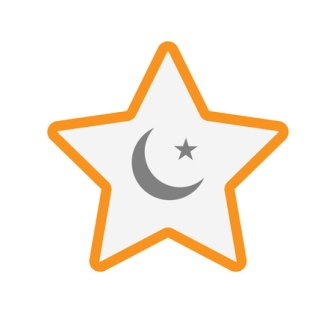What kind of story can you create with this symbol involving a mythical creature? In a realm where the skies are in constant twilight, there existed a legendary creature known as the Stellarion. This magnificent being was said to be birthed from a conjunction of the largest star and its moon. The Stellarion possessed the power to bring balance to the natural order. Whenever a shadow of chaos threatened the lands, the creature would emerge, its body glowing with the vibrant orange of the star and the calming gray of the moon. It was believed that the Stellarion could control the tides, summon rain, and even guide lost souls through the night. Its presence was a beacon of hope and harmony, reminding all of the intrinsic balance of the universe. Describe a scene where the Stellarion uses its powers to restore balance during a crisis. The skies darkened ominously as a foul tempest brewed over the tranquil land of Lumaria. The usual gentle winds turned savage, and torrential rain threatened to flood the sacred valleys. Panic spread among the Lumariens as their crops and homes were at the mercy of the unforgiving storm. In the midst of this chaos, a radiant glow began to pierce the dark clouds. From the heart of the storm, the Stellarion descended, with its star-and-moon adorned form illuminating the surroundings. With a graceful yet powerful sweep of its wings, the Stellarion calmed the raging winds and silenced the thunderous clouds. Its ethereal light infused into the waters, purifying and gently steering them back to the earth, revitalizing the crops and quenching the land. The Lumariens watched in awe and cheered as the Stellarion restored balance, demonstrating the harmonious power that lies within the cosmos. 